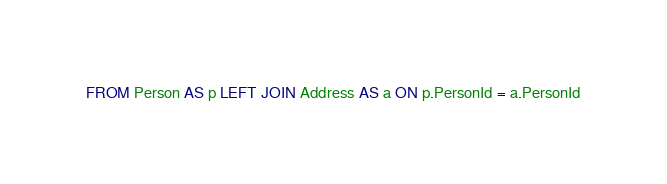Convert code to text. <code><loc_0><loc_0><loc_500><loc_500><_SQL_>FROM Person AS p LEFT JOIN Address AS a ON p.PersonId = a.PersonId
</code> 